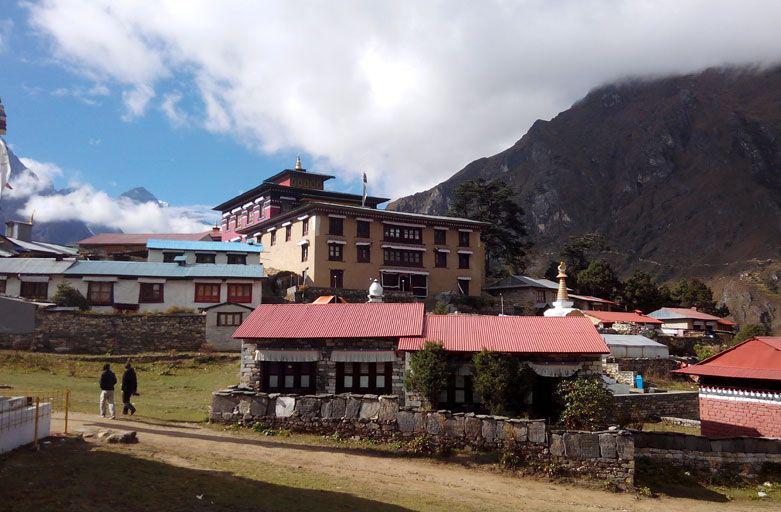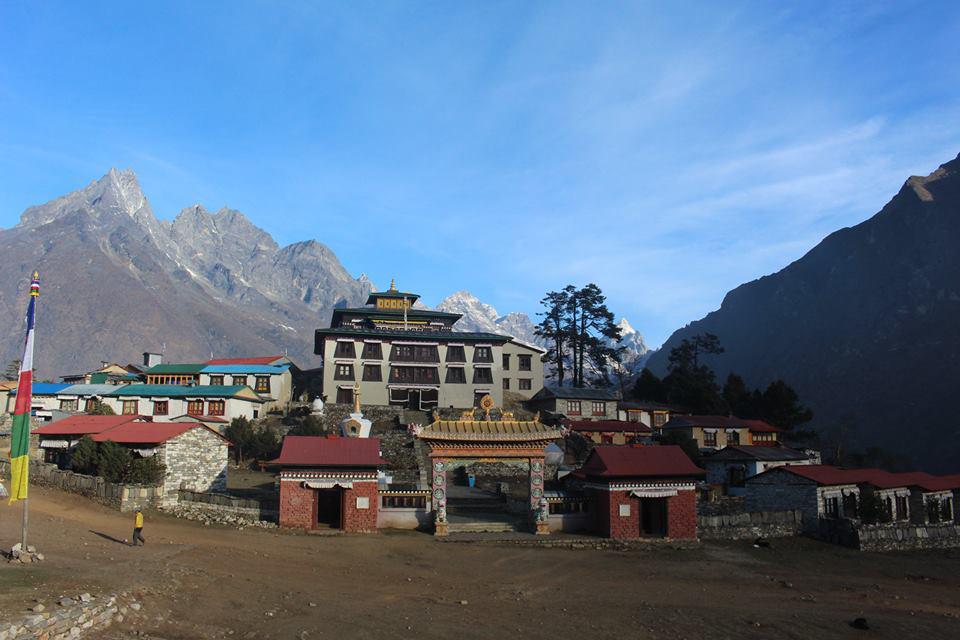The first image is the image on the left, the second image is the image on the right. Assess this claim about the two images: "In the right image, a neutral colored building with at least eight windows on its front is on a hillside with mountains in the background.". Correct or not? Answer yes or no. Yes. 